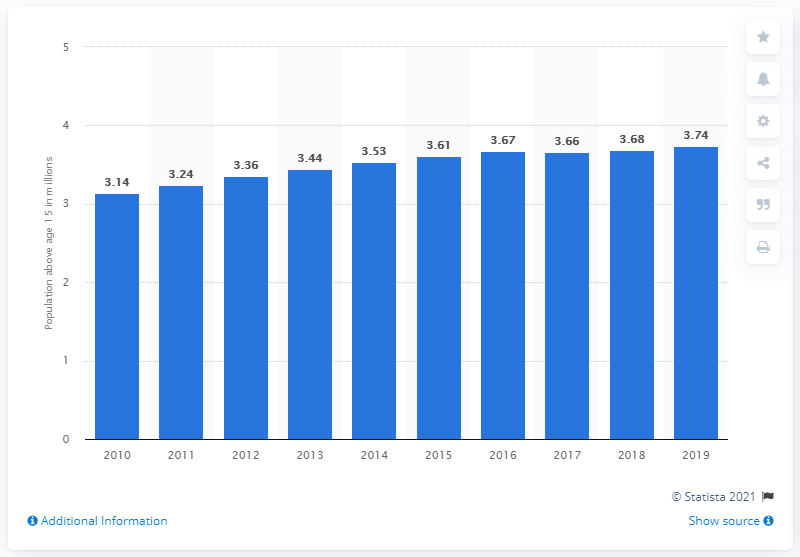Give some essential details in this illustration. In June 2019, there were approximately 3.74 million people in Singapore's working-age labor force. 